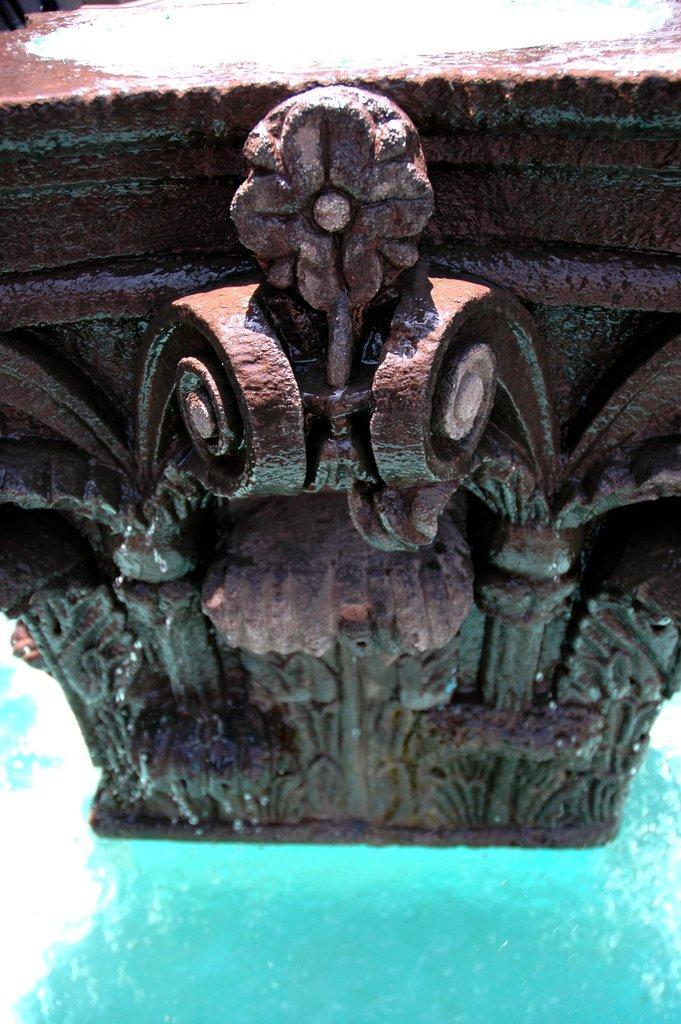Could you give a brief overview of what you see in this image? In this picture we can see a carved stone here, at the bottom there is water. 